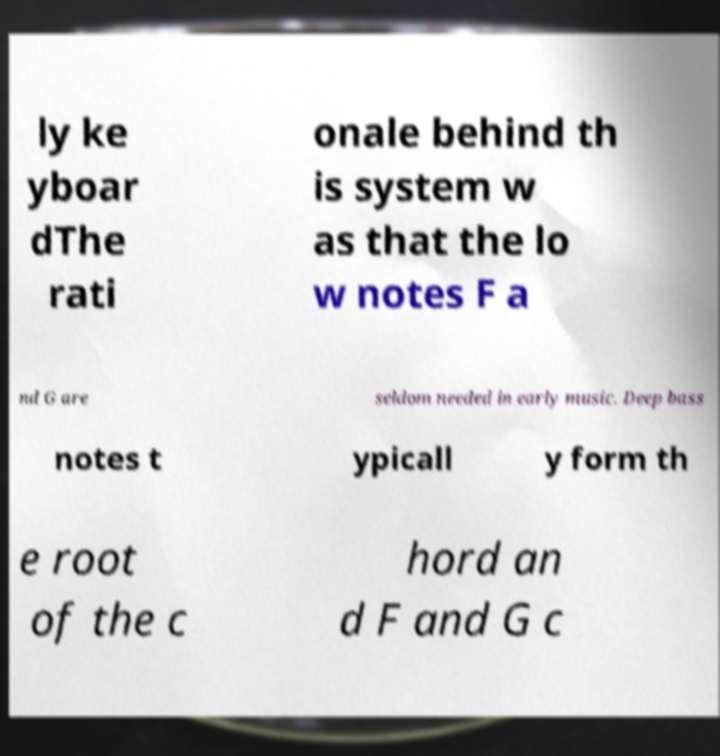What messages or text are displayed in this image? I need them in a readable, typed format. ly ke yboar dThe rati onale behind th is system w as that the lo w notes F a nd G are seldom needed in early music. Deep bass notes t ypicall y form th e root of the c hord an d F and G c 